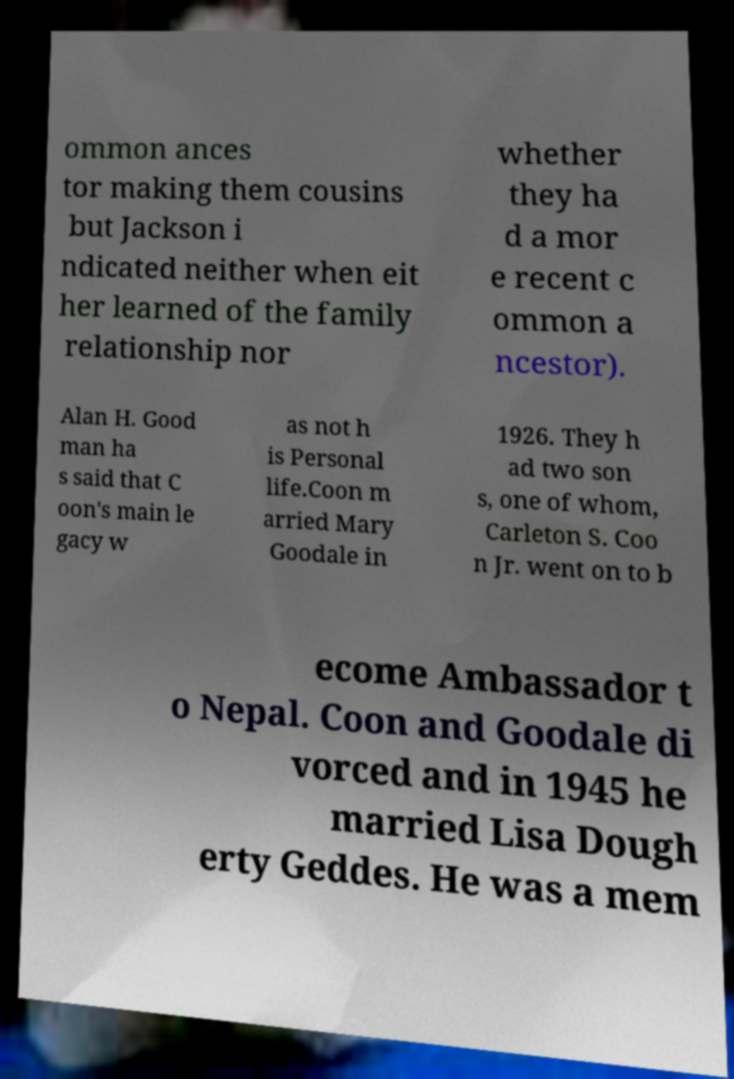I need the written content from this picture converted into text. Can you do that? ommon ances tor making them cousins but Jackson i ndicated neither when eit her learned of the family relationship nor whether they ha d a mor e recent c ommon a ncestor). Alan H. Good man ha s said that C oon's main le gacy w as not h is Personal life.Coon m arried Mary Goodale in 1926. They h ad two son s, one of whom, Carleton S. Coo n Jr. went on to b ecome Ambassador t o Nepal. Coon and Goodale di vorced and in 1945 he married Lisa Dough erty Geddes. He was a mem 